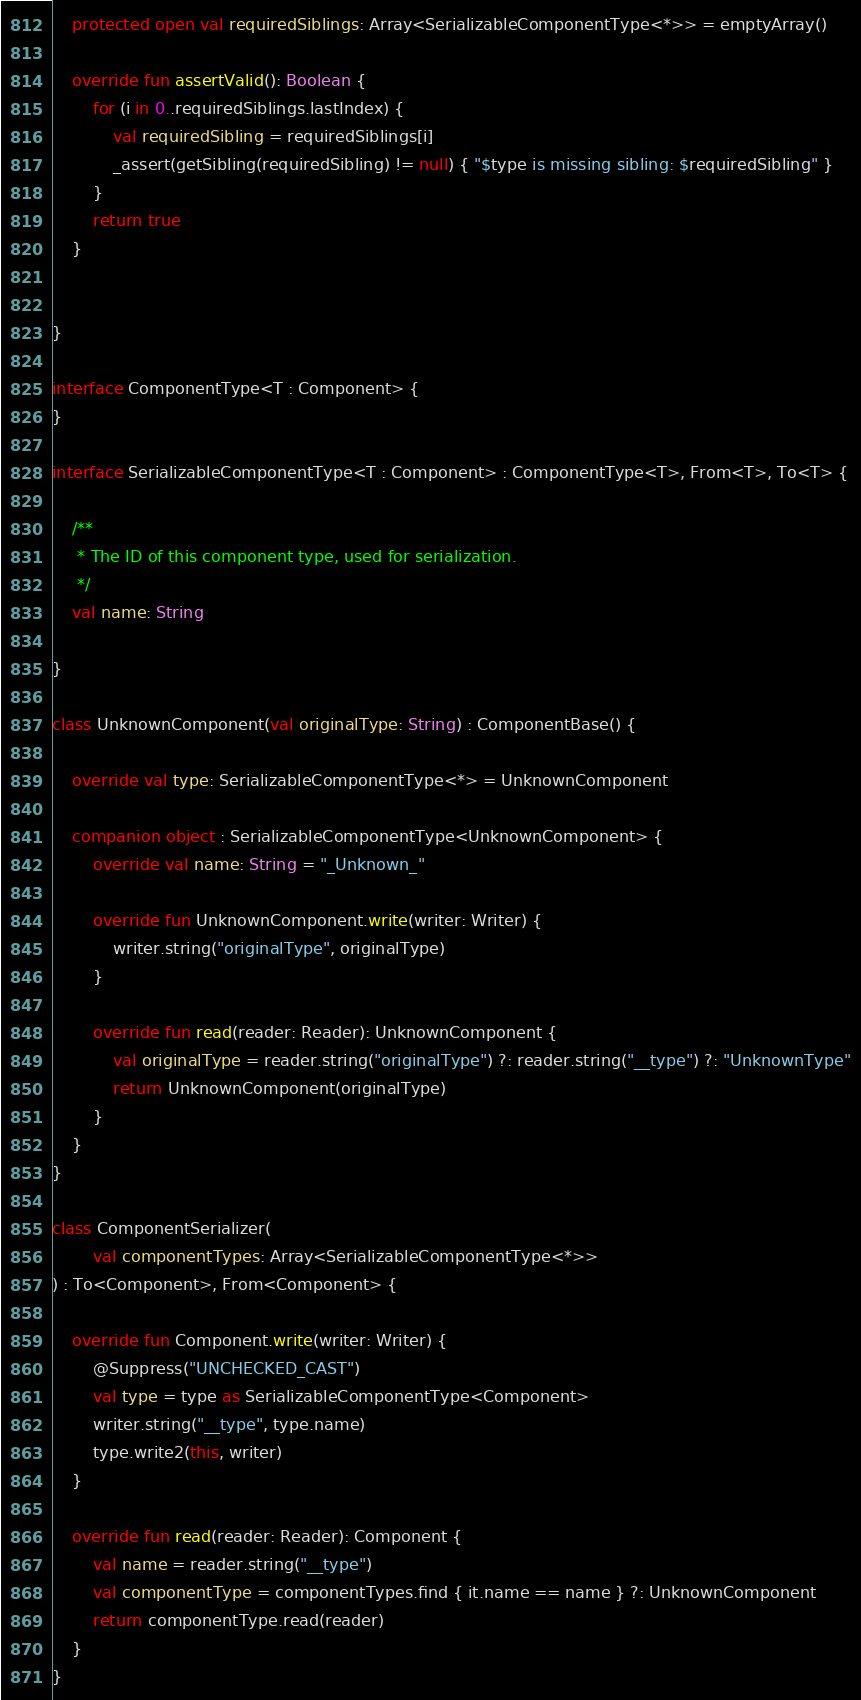<code> <loc_0><loc_0><loc_500><loc_500><_Kotlin_>
	protected open val requiredSiblings: Array<SerializableComponentType<*>> = emptyArray()

	override fun assertValid(): Boolean {
		for (i in 0..requiredSiblings.lastIndex) {
			val requiredSibling = requiredSiblings[i]
			_assert(getSibling(requiredSibling) != null) { "$type is missing sibling: $requiredSibling" }
		}
		return true
	}


}

interface ComponentType<T : Component> {
}

interface SerializableComponentType<T : Component> : ComponentType<T>, From<T>, To<T> {

	/**
	 * The ID of this component type, used for serialization.
	 */
	val name: String

}

class UnknownComponent(val originalType: String) : ComponentBase() {

	override val type: SerializableComponentType<*> = UnknownComponent

	companion object : SerializableComponentType<UnknownComponent> {
		override val name: String = "_Unknown_"

		override fun UnknownComponent.write(writer: Writer) {
			writer.string("originalType", originalType)
		}

		override fun read(reader: Reader): UnknownComponent {
			val originalType = reader.string("originalType") ?: reader.string("__type") ?: "UnknownType"
			return UnknownComponent(originalType)
		}
	}
}

class ComponentSerializer(
		val componentTypes: Array<SerializableComponentType<*>>
) : To<Component>, From<Component> {

	override fun Component.write(writer: Writer) {
		@Suppress("UNCHECKED_CAST")
		val type = type as SerializableComponentType<Component>
		writer.string("__type", type.name)
		type.write2(this, writer)
	}

	override fun read(reader: Reader): Component {
		val name = reader.string("__type")
		val componentType = componentTypes.find { it.name == name } ?: UnknownComponent
		return componentType.read(reader)
	}
}

</code> 